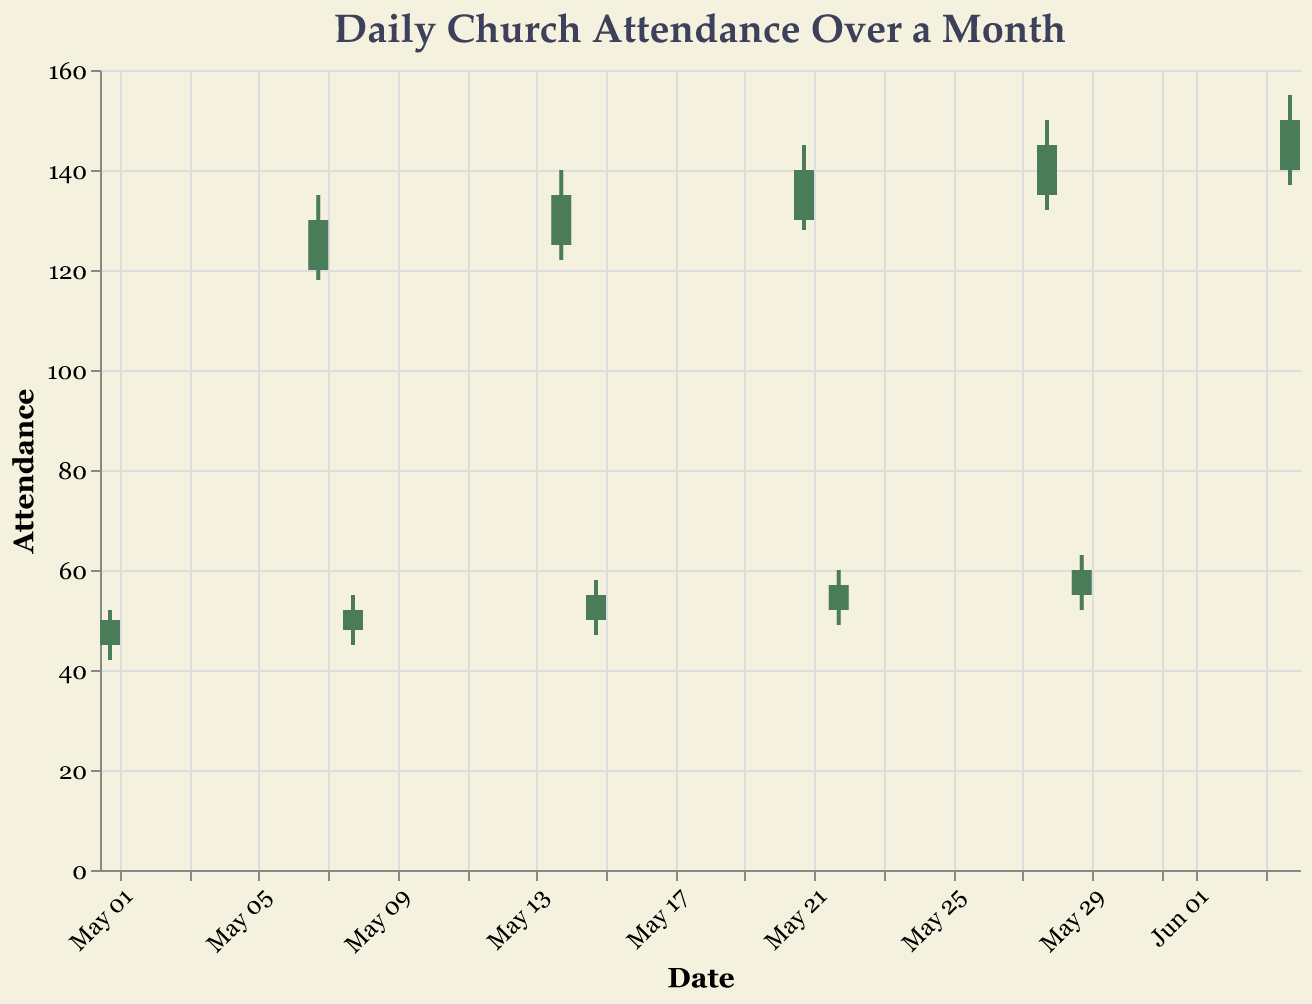What is the title of the chart? The title of the chart is written at the top in a larger font size.
Answer: Daily Church Attendance Over a Month On which date was the lowest daily attendance recorded? The lowest attendance should be identified from the "Low" value corresponding to each date.
Answer: 2023-05-01 How does the attendance on May 1st compare to the following weekend, May 7th? To compare, look at the "Close" value for May 1st (50) and May 7th (130). The attendance increased over the weekend.
Answer: May 7th had higher attendance than May 1st Calculate the average "Close" attendance for weekends in May. The weekends in May are May 7, May 14, May 21, and May 28, with "Close" values of 130, 135, 140, and 145 respectively. Sum these values (130+135+140+145 = 550) and divide by the number of weekends (4).
Answer: 137.5 Which day had the highest "High" attendance, and what was the value? Look for the highest "High" value across all dates.
Answer: June 4th had the highest High attendance of 155 Compare the "Close" attendance between May 29th and June 4th. Which day had a higher closing attendance? Compare the "Close" value on May 29 (60) and June 4 (150).
Answer: June 4th What pattern can be observed in church attendance between weekdays and weekends? Identify and compare the attendance trend, noting that weekends show higher attendance figures.
Answer: Weekends have higher attendance What is the range of attendance recorded on May 28th? The range is calculated by subtracting the "Low" value from the "High" value for that date. For May 28th, it is 150 - 132.
Answer: 18 On which dates did the closing attendance exceed the opening attendance? Compare the "Open" and "Close" values for each date to identify where "Close" is greater than "Open".
Answer: May 7, May 14, May 21, May 28, and June 4 What is the overall trend in church attendance from the beginning to the end of the period shown? By looking at the "Close" values from May 1 (50) to June 4 (150), we can see if there is an increasing or decreasing trend.
Answer: Increasing trend 